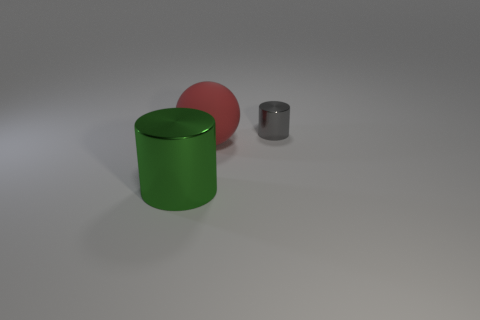Is there any other thing that has the same size as the red sphere? While it's not possible to determine the exact size from this angle, the gray cylinder appears to be smaller than the red sphere, and the green cylinder seems larger. Therefore, based on the visible perspectives, there is no object identical in size to the red sphere in the image provided. 